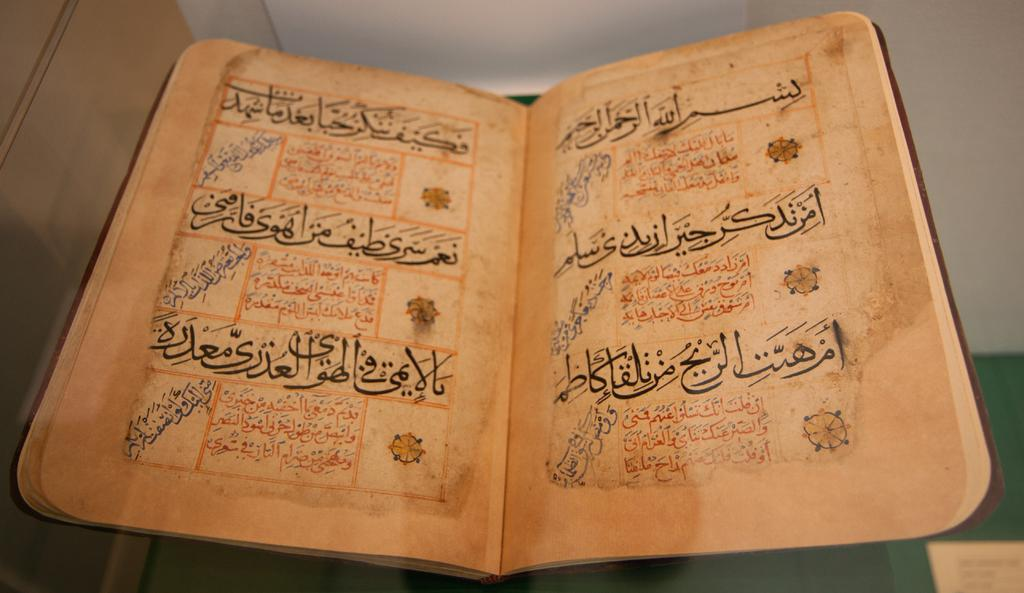What is the main object in the image? There is a book in the image. What other items with text can be seen in the image? There are papers with text in the image. What color is the background of the image? The background of the image is white. Where is the text located in the image? There is text visible at the bottom right corner of the image. What type of tools does the carpenter use in the image? There is no carpenter or tools present in the image. What is the chance of winning a prize in the image? There is no reference to a prize or chance in the image. 